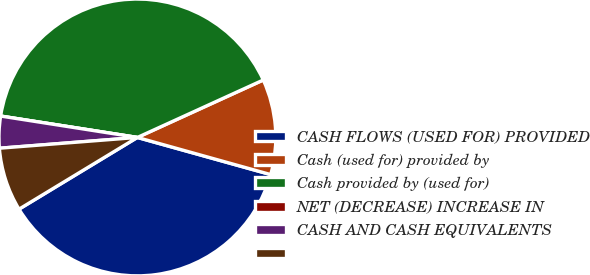<chart> <loc_0><loc_0><loc_500><loc_500><pie_chart><fcel>CASH FLOWS (USED FOR) PROVIDED<fcel>Cash (used for) provided by<fcel>Cash provided by (used for)<fcel>NET (DECREASE) INCREASE IN<fcel>CASH AND CASH EQUIVALENTS<fcel>Unnamed: 5<nl><fcel>37.01%<fcel>11.14%<fcel>40.72%<fcel>0.0%<fcel>3.71%<fcel>7.43%<nl></chart> 